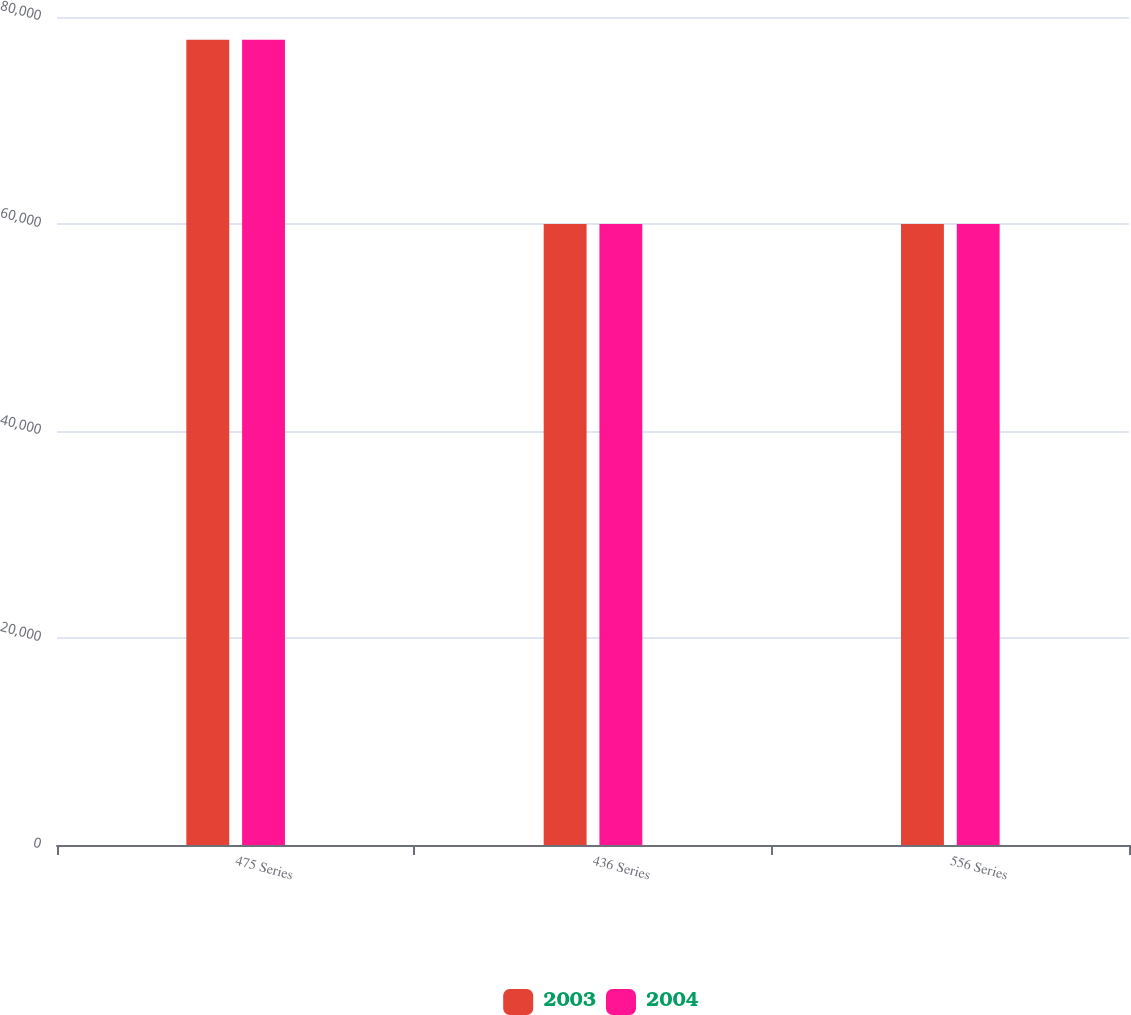Convert chart. <chart><loc_0><loc_0><loc_500><loc_500><stacked_bar_chart><ecel><fcel>475 Series<fcel>436 Series<fcel>556 Series<nl><fcel>2003<fcel>77798<fcel>60000<fcel>60000<nl><fcel>2004<fcel>77798<fcel>60000<fcel>60000<nl></chart> 